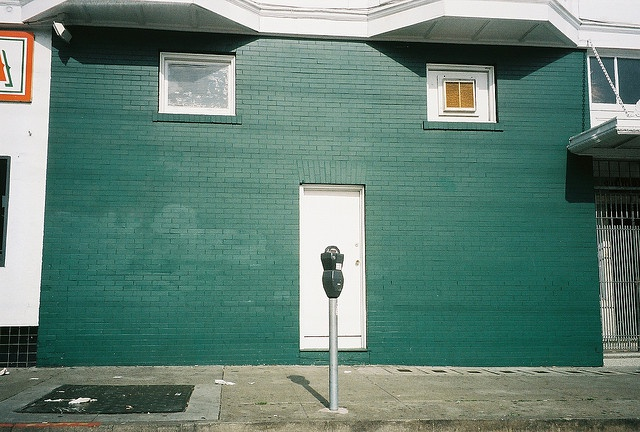Describe the objects in this image and their specific colors. I can see a parking meter in lightgray, gray, black, and teal tones in this image. 